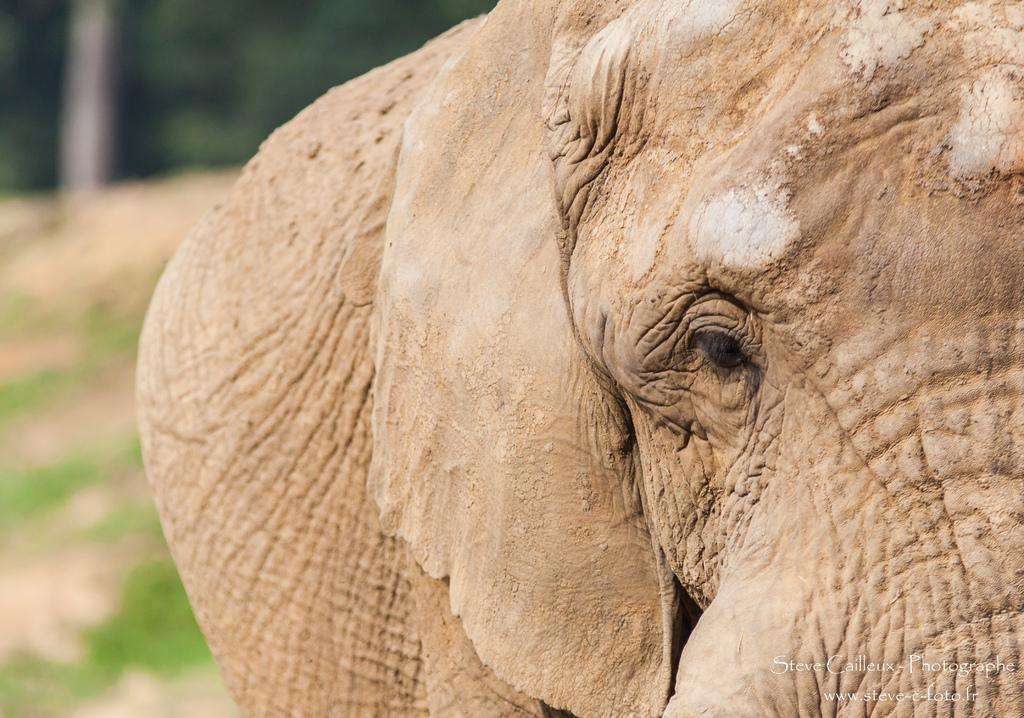What animal is the main subject of the picture? There is an elephant in the picture. What color is the statement made by the elephant in the picture? There is no statement made by the elephant in the picture, as elephants do not communicate through written statements. 